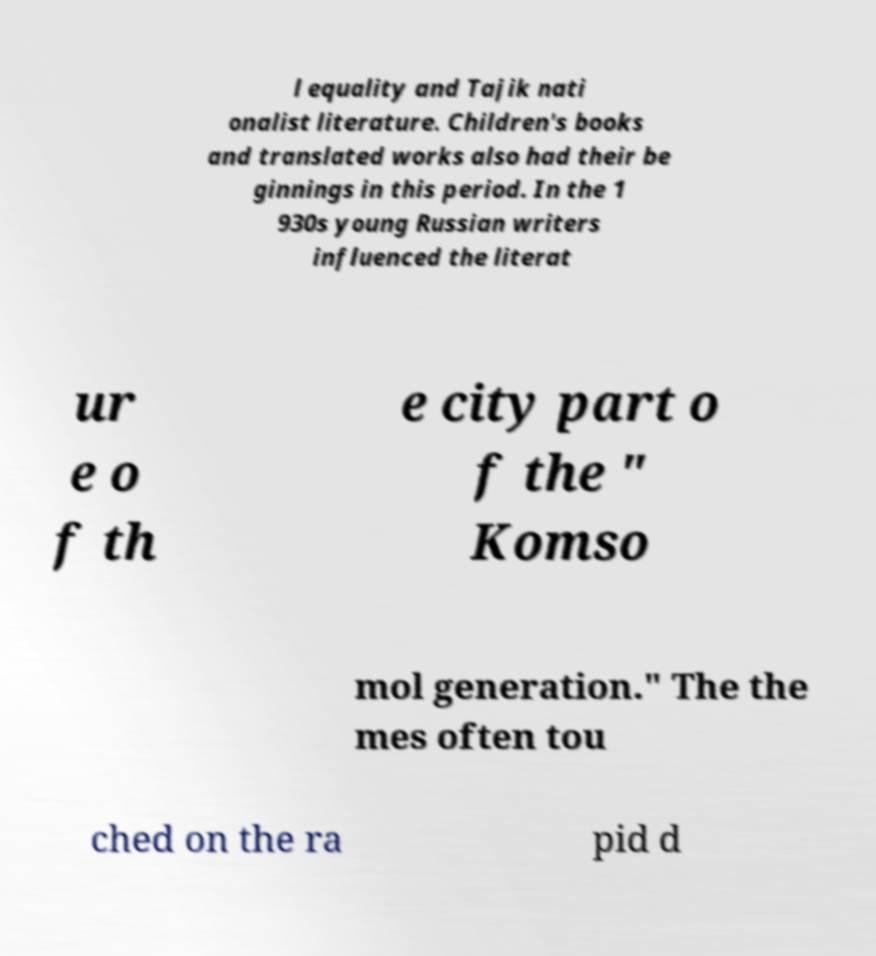For documentation purposes, I need the text within this image transcribed. Could you provide that? l equality and Tajik nati onalist literature. Children's books and translated works also had their be ginnings in this period. In the 1 930s young Russian writers influenced the literat ur e o f th e city part o f the " Komso mol generation." The the mes often tou ched on the ra pid d 